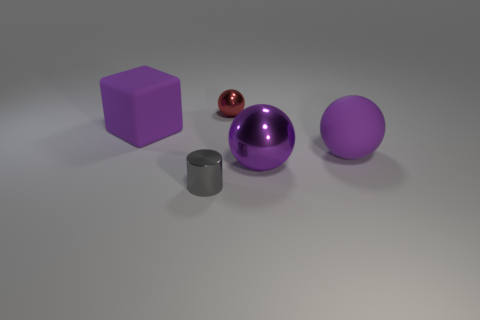Subtract all large purple matte spheres. How many spheres are left? 2 Subtract all red spheres. How many spheres are left? 2 Subtract 0 purple cylinders. How many objects are left? 5 Subtract all balls. How many objects are left? 2 Subtract 1 spheres. How many spheres are left? 2 Subtract all brown balls. Subtract all blue cylinders. How many balls are left? 3 Subtract all yellow cylinders. How many cyan cubes are left? 0 Subtract all gray matte cylinders. Subtract all large purple matte cubes. How many objects are left? 4 Add 3 red metal balls. How many red metal balls are left? 4 Add 2 large purple blocks. How many large purple blocks exist? 3 